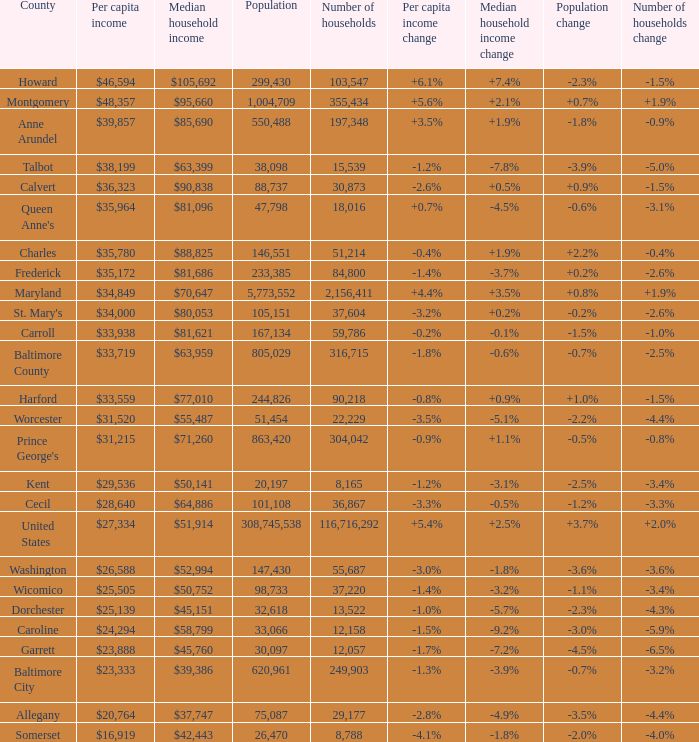Help me parse the entirety of this table. {'header': ['County', 'Per capita income', 'Median household income', 'Population', 'Number of households', 'Per capita income change', 'Median household income change', 'Population change', 'Number of households change'], 'rows': [['Howard', '$46,594', '$105,692', '299,430', '103,547', '+6.1%', '+7.4%', '-2.3%', '-1.5%'], ['Montgomery', '$48,357', '$95,660', '1,004,709', '355,434', '+5.6%', '+2.1%', '+0.7%', '+1.9%'], ['Anne Arundel', '$39,857', '$85,690', '550,488', '197,348', '+3.5%', '+1.9%', '-1.8%', '-0.9%'], ['Talbot', '$38,199', '$63,399', '38,098', '15,539', '-1.2%', '-7.8%', '-3.9%', '-5.0%'], ['Calvert', '$36,323', '$90,838', '88,737', '30,873', '-2.6%', '+0.5%', '+0.9%', '-1.5%'], ["Queen Anne's", '$35,964', '$81,096', '47,798', '18,016', '+0.7%', '-4.5%', '-0.6%', '-3.1%'], ['Charles', '$35,780', '$88,825', '146,551', '51,214', '-0.4%', '+1.9%', '+2.2%', '-0.4%'], ['Frederick', '$35,172', '$81,686', '233,385', '84,800', '-1.4%', '-3.7%', '+0.2%', '-2.6%'], ['Maryland', '$34,849', '$70,647', '5,773,552', '2,156,411', '+4.4%', '+3.5%', '+0.8%', '+1.9%'], ["St. Mary's", '$34,000', '$80,053', '105,151', '37,604', '-3.2%', '+0.2%', '-0.2%', '-2.6%'], ['Carroll', '$33,938', '$81,621', '167,134', '59,786', '-0.2%', '-0.1%', '-1.5%', '-1.0%'], ['Baltimore County', '$33,719', '$63,959', '805,029', '316,715', '-1.8%', '-0.6%', '-0.7%', '-2.5%'], ['Harford', '$33,559', '$77,010', '244,826', '90,218', '-0.8%', '+0.9%', '+1.0%', '-1.5%'], ['Worcester', '$31,520', '$55,487', '51,454', '22,229', '-3.5%', '-5.1%', '-2.2%', '-4.4%'], ["Prince George's", '$31,215', '$71,260', '863,420', '304,042', '-0.9%', '+1.1%', '-0.5%', '-0.8%'], ['Kent', '$29,536', '$50,141', '20,197', '8,165', '-1.2%', '-3.1%', '-2.5%', '-3.4%'], ['Cecil', '$28,640', '$64,886', '101,108', '36,867', '-3.3%', '-0.5%', '-1.2%', '-3.3%'], ['United States', '$27,334', '$51,914', '308,745,538', '116,716,292', '+5.4%', '+2.5%', '+3.7%', '+2.0%'], ['Washington', '$26,588', '$52,994', '147,430', '55,687', '-3.0%', '-1.8%', '-3.6%', '-3.6%'], ['Wicomico', '$25,505', '$50,752', '98,733', '37,220', '-1.4%', '-3.2%', '-1.1%', '-3.4%'], ['Dorchester', '$25,139', '$45,151', '32,618', '13,522', '-1.0%', '-5.7%', '-2.3%', '-4.3%'], ['Caroline', '$24,294', '$58,799', '33,066', '12,158', '-1.5%', '-9.2%', '-3.0%', '-5.9%'], ['Garrett', '$23,888', '$45,760', '30,097', '12,057', '-1.7%', '-7.2%', '-4.5%', '-6.5%'], ['Baltimore City', '$23,333', '$39,386', '620,961', '249,903', '-1.3%', '-3.9%', '-0.7%', '-3.2%'], ['Allegany', '$20,764', '$37,747', '75,087', '29,177', '-2.8%', '-4.9%', '-3.5%', '-4.4%'], ['Somerset', '$16,919', '$42,443', '26,470', '8,788', '-4.1%', '-1.8%', '-2.0%', '-4.0%']]} What is the per capital income for Charles county? $35,780. 